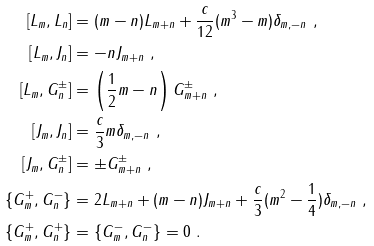<formula> <loc_0><loc_0><loc_500><loc_500>\left [ L _ { m } , L _ { n } \right ] & = ( m - n ) L _ { m + n } + \frac { c } { 1 2 } ( m ^ { 3 } - m ) \delta _ { m , - n } \ , \\ \left [ L _ { m } , J _ { n } \right ] & = - n J _ { m + n } \ , \\ \left [ L _ { m } , G _ { n } ^ { \pm } \right ] & = \left ( \frac { 1 } { 2 } m - n \right ) G _ { m + n } ^ { \pm } \ , \\ \left [ J _ { m } , J _ { n } \right ] & = \frac { c } { 3 } m \delta _ { m , - n } \ , \\ \left [ J _ { m } , G _ { n } ^ { \pm } \right ] & = \pm G _ { m + n } ^ { \pm } \ , \\ \left \{ G _ { m } ^ { + } , G _ { n } ^ { - } \right \} & = 2 L _ { m + n } + ( m - n ) J _ { m + n } + \frac { c } { 3 } ( m ^ { 2 } - \frac { 1 } { 4 } ) \delta _ { m , - n } \ , \\ \left \{ G _ { m } ^ { + } , G _ { n } ^ { + } \right \} & = \left \{ G _ { m } ^ { - } , G _ { n } ^ { - } \right \} = 0 \ .</formula> 